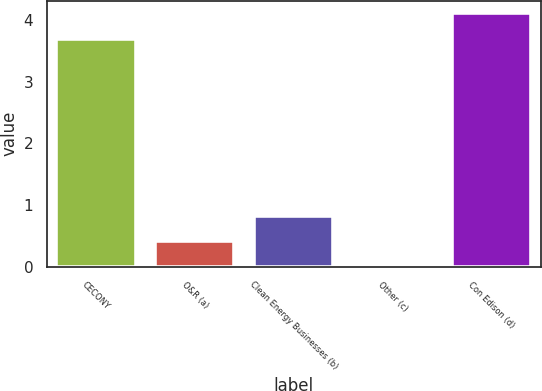<chart> <loc_0><loc_0><loc_500><loc_500><bar_chart><fcel>CECONY<fcel>O&R (a)<fcel>Clean Energy Businesses (b)<fcel>Other (c)<fcel>Con Edison (d)<nl><fcel>3.7<fcel>0.42<fcel>0.83<fcel>0.01<fcel>4.11<nl></chart> 